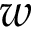<formula> <loc_0><loc_0><loc_500><loc_500>w</formula> 